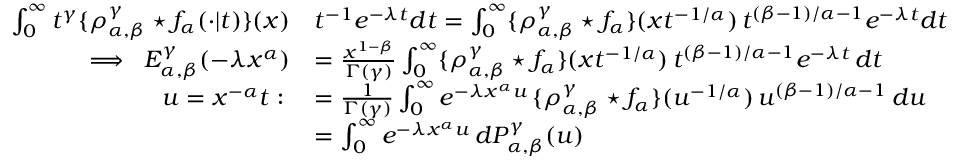Convert formula to latex. <formula><loc_0><loc_0><loc_500><loc_500>\begin{array} { r l } { \int _ { 0 } ^ { \infty } t ^ { \gamma } \{ \rho _ { \alpha , \beta } ^ { \gamma } ^ { * } f _ { \alpha } ( \cdot | t ) \} ( x ) } & { t ^ { - 1 } e ^ { - \lambda t } d t = \int _ { 0 } ^ { \infty } \{ \rho _ { \alpha , \beta } ^ { \gamma } ^ { * } f _ { \alpha } \} ( x t ^ { - 1 / \alpha } ) \, t ^ { ( \beta - 1 ) / \alpha - 1 } e ^ { - \lambda t } d t } \\ { \implies \, E _ { \alpha , \beta } ^ { \gamma } ( - \lambda x ^ { \alpha } ) } & { = \frac { x ^ { 1 - \beta } } { \Gamma ( \gamma ) } \int _ { 0 } ^ { \infty } \{ \rho _ { \alpha , \beta } ^ { \gamma } ^ { * } f _ { \alpha } \} ( x t ^ { - 1 / \alpha } ) \, t ^ { ( \beta - 1 ) / \alpha - 1 } e ^ { - \lambda t } \, d t } \\ { u = x ^ { - \alpha } t \colon \, } & { = \frac { 1 } { \Gamma ( \gamma ) } \int _ { 0 } ^ { \infty } e ^ { - \lambda x ^ { \alpha } u } \, \{ \rho _ { \alpha , \beta } ^ { \gamma } ^ { * } f _ { \alpha } \} ( u ^ { - 1 / \alpha } ) \, u ^ { ( \beta - 1 ) / \alpha - 1 } \, d u } \\ & { = \int _ { 0 } ^ { \infty } e ^ { - \lambda x ^ { \alpha } u } \, d P _ { \alpha , \beta } ^ { \gamma } ( u ) } \end{array}</formula> 